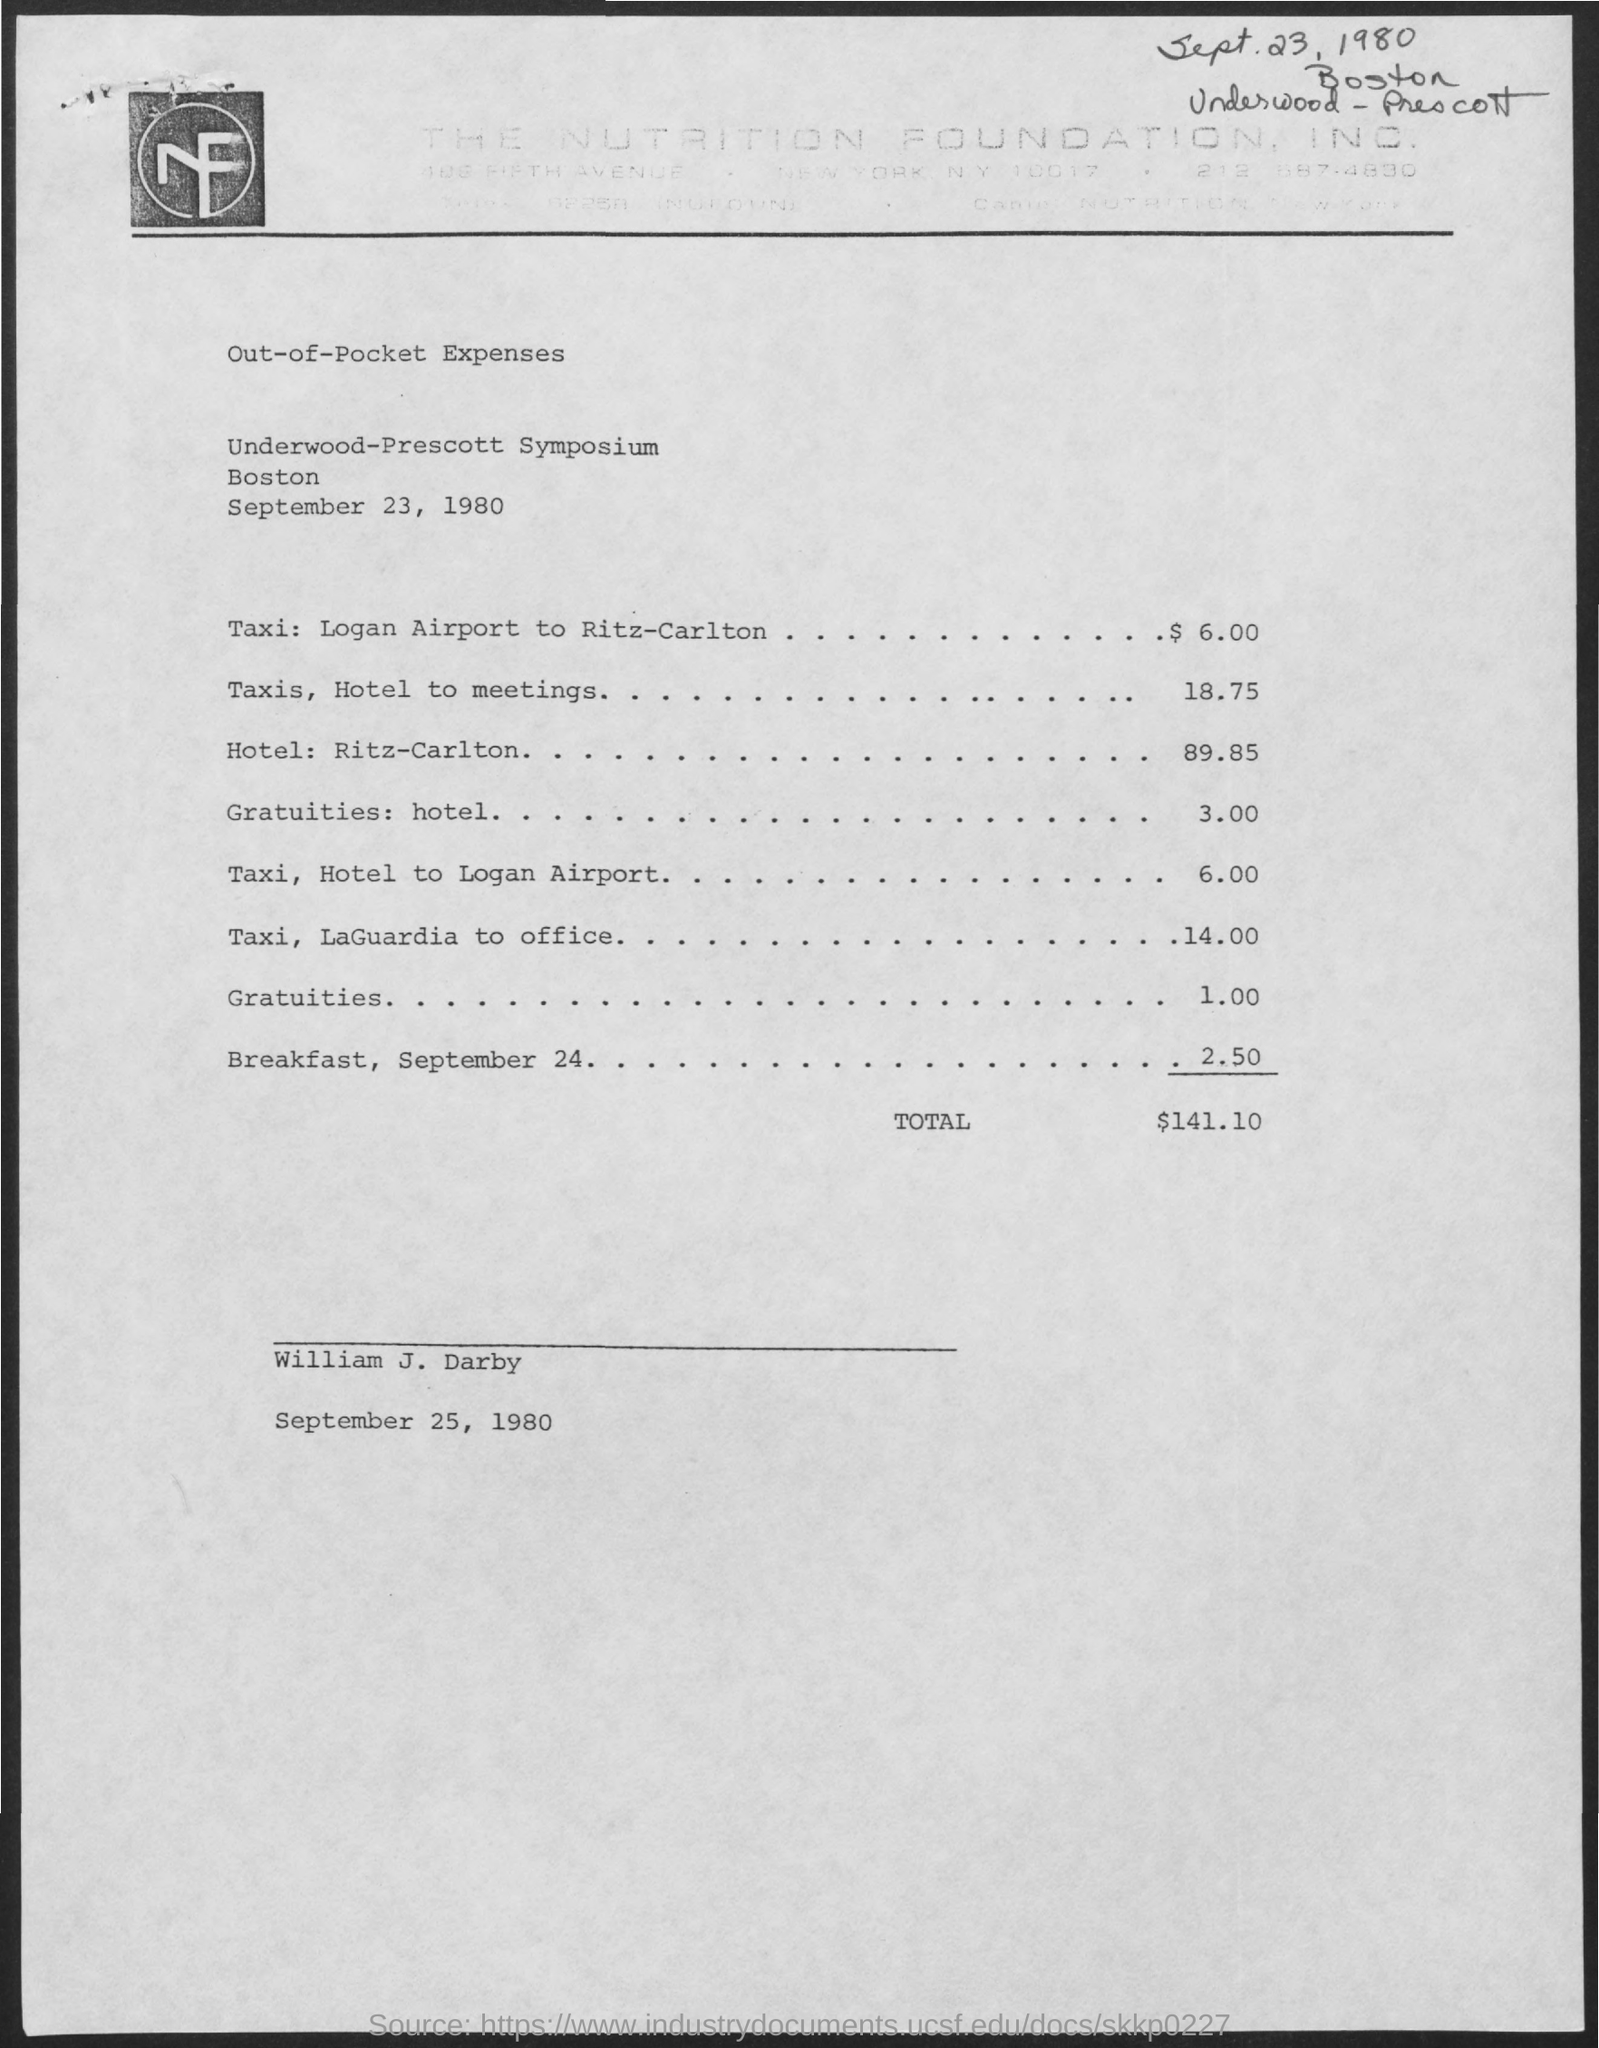How much expenses does gratuities: hotel include?
Provide a succinct answer. 3.00. What is the total expenses?
Your answer should be very brief. $141.10. 